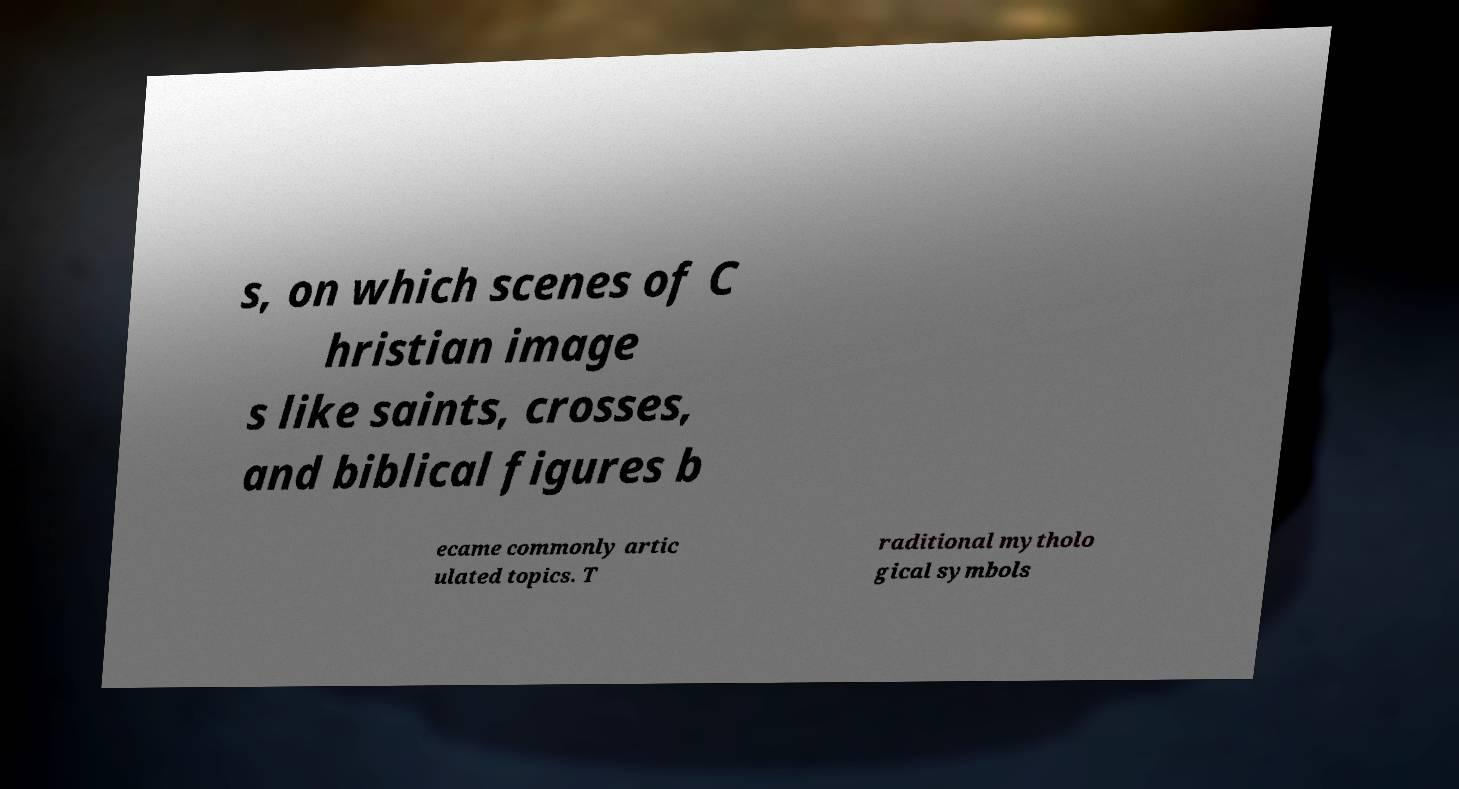What messages or text are displayed in this image? I need them in a readable, typed format. s, on which scenes of C hristian image s like saints, crosses, and biblical figures b ecame commonly artic ulated topics. T raditional mytholo gical symbols 